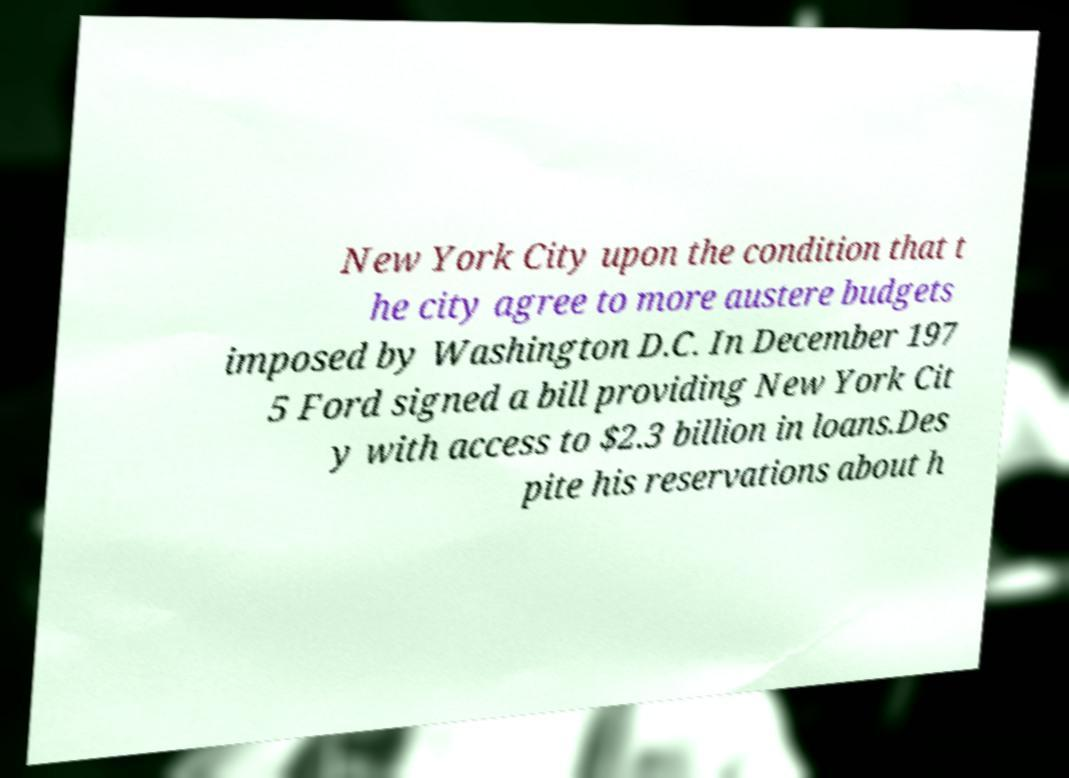Can you read and provide the text displayed in the image?This photo seems to have some interesting text. Can you extract and type it out for me? New York City upon the condition that t he city agree to more austere budgets imposed by Washington D.C. In December 197 5 Ford signed a bill providing New York Cit y with access to $2.3 billion in loans.Des pite his reservations about h 